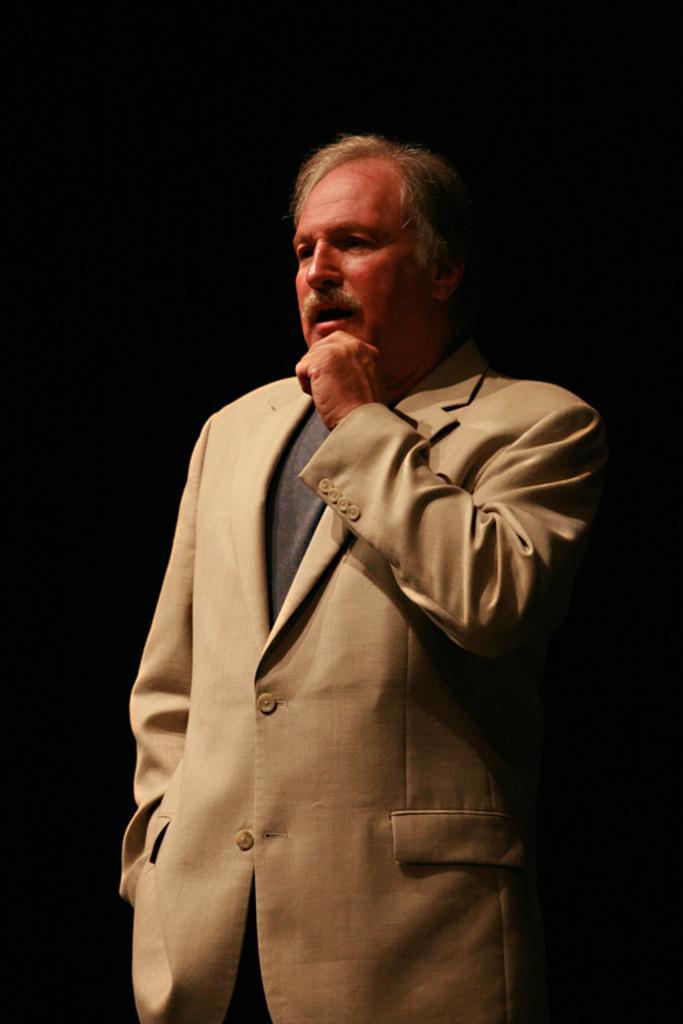Could you give a brief overview of what you see in this image? In this image I can see a person standing, wearing a suit. There is a black background. 